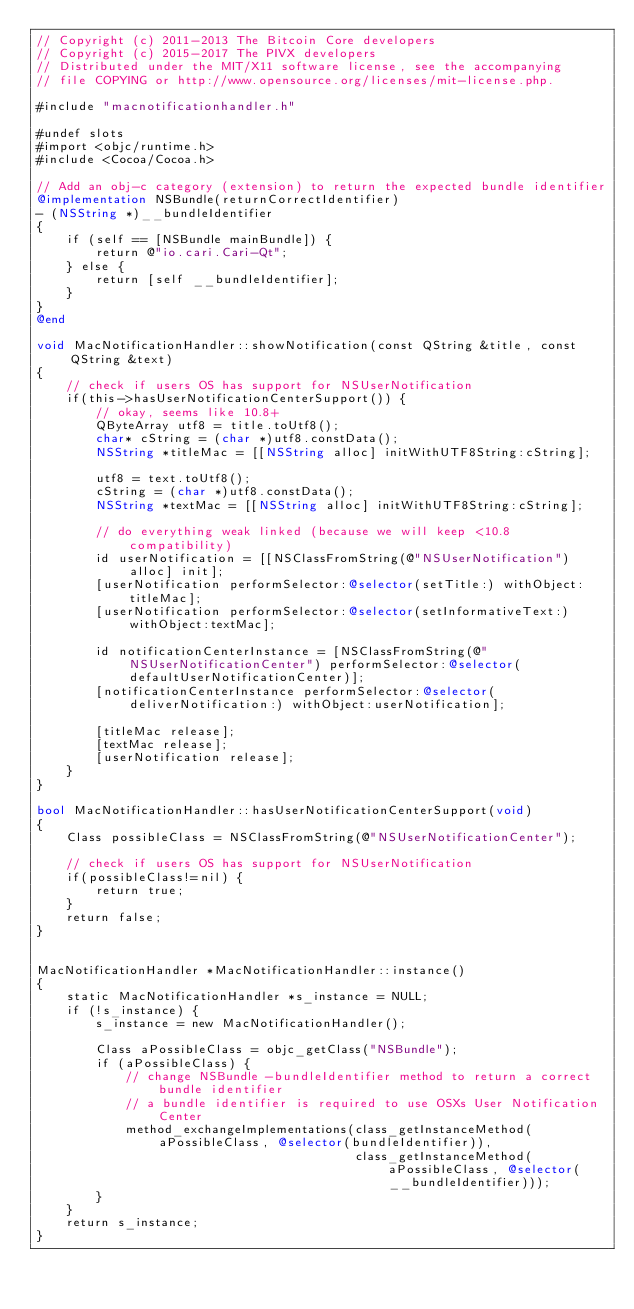Convert code to text. <code><loc_0><loc_0><loc_500><loc_500><_ObjectiveC_>// Copyright (c) 2011-2013 The Bitcoin Core developers
// Copyright (c) 2015-2017 The PIVX developers
// Distributed under the MIT/X11 software license, see the accompanying
// file COPYING or http://www.opensource.org/licenses/mit-license.php.

#include "macnotificationhandler.h"

#undef slots
#import <objc/runtime.h>
#include <Cocoa/Cocoa.h>

// Add an obj-c category (extension) to return the expected bundle identifier
@implementation NSBundle(returnCorrectIdentifier)
- (NSString *)__bundleIdentifier
{
    if (self == [NSBundle mainBundle]) {
        return @"io.cari.Cari-Qt";
    } else {
        return [self __bundleIdentifier];
    }
}
@end

void MacNotificationHandler::showNotification(const QString &title, const QString &text)
{
    // check if users OS has support for NSUserNotification
    if(this->hasUserNotificationCenterSupport()) {
        // okay, seems like 10.8+
        QByteArray utf8 = title.toUtf8();
        char* cString = (char *)utf8.constData();
        NSString *titleMac = [[NSString alloc] initWithUTF8String:cString];

        utf8 = text.toUtf8();
        cString = (char *)utf8.constData();
        NSString *textMac = [[NSString alloc] initWithUTF8String:cString];

        // do everything weak linked (because we will keep <10.8 compatibility)
        id userNotification = [[NSClassFromString(@"NSUserNotification") alloc] init];
        [userNotification performSelector:@selector(setTitle:) withObject:titleMac];
        [userNotification performSelector:@selector(setInformativeText:) withObject:textMac];

        id notificationCenterInstance = [NSClassFromString(@"NSUserNotificationCenter") performSelector:@selector(defaultUserNotificationCenter)];
        [notificationCenterInstance performSelector:@selector(deliverNotification:) withObject:userNotification];

        [titleMac release];
        [textMac release];
        [userNotification release];
    }
}

bool MacNotificationHandler::hasUserNotificationCenterSupport(void)
{
    Class possibleClass = NSClassFromString(@"NSUserNotificationCenter");

    // check if users OS has support for NSUserNotification
    if(possibleClass!=nil) {
        return true;
    }
    return false;
}


MacNotificationHandler *MacNotificationHandler::instance()
{
    static MacNotificationHandler *s_instance = NULL;
    if (!s_instance) {
        s_instance = new MacNotificationHandler();
        
        Class aPossibleClass = objc_getClass("NSBundle");
        if (aPossibleClass) {
            // change NSBundle -bundleIdentifier method to return a correct bundle identifier
            // a bundle identifier is required to use OSXs User Notification Center
            method_exchangeImplementations(class_getInstanceMethod(aPossibleClass, @selector(bundleIdentifier)),
                                           class_getInstanceMethod(aPossibleClass, @selector(__bundleIdentifier)));
        }
    }
    return s_instance;
}
</code> 